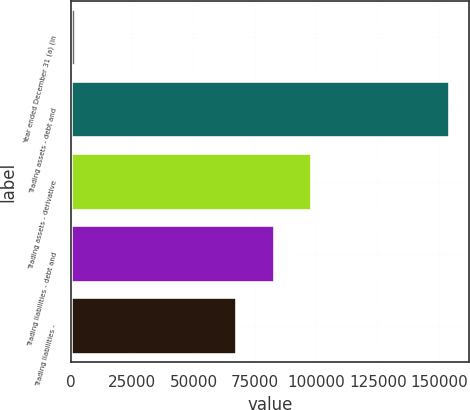Convert chart. <chart><loc_0><loc_0><loc_500><loc_500><bar_chart><fcel>Year ended December 31 (a) (in<fcel>Trading assets - debt and<fcel>Trading assets - derivative<fcel>Trading liabilities - debt and<fcel>Trading liabilities -<nl><fcel>2003<fcel>154597<fcel>98301.8<fcel>83042.4<fcel>67783<nl></chart> 